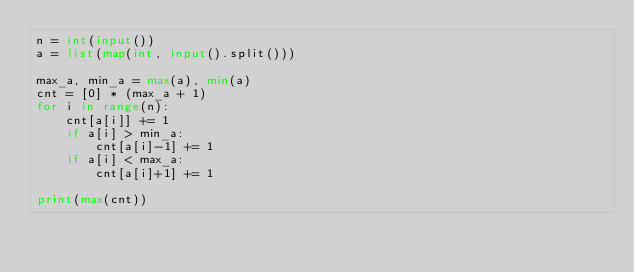<code> <loc_0><loc_0><loc_500><loc_500><_Python_>n = int(input())
a = list(map(int, input().split()))

max_a, min_a = max(a), min(a)
cnt = [0] * (max_a + 1)
for i in range(n):
    cnt[a[i]] += 1
    if a[i] > min_a:
        cnt[a[i]-1] += 1
    if a[i] < max_a:
        cnt[a[i]+1] += 1

print(max(cnt))</code> 